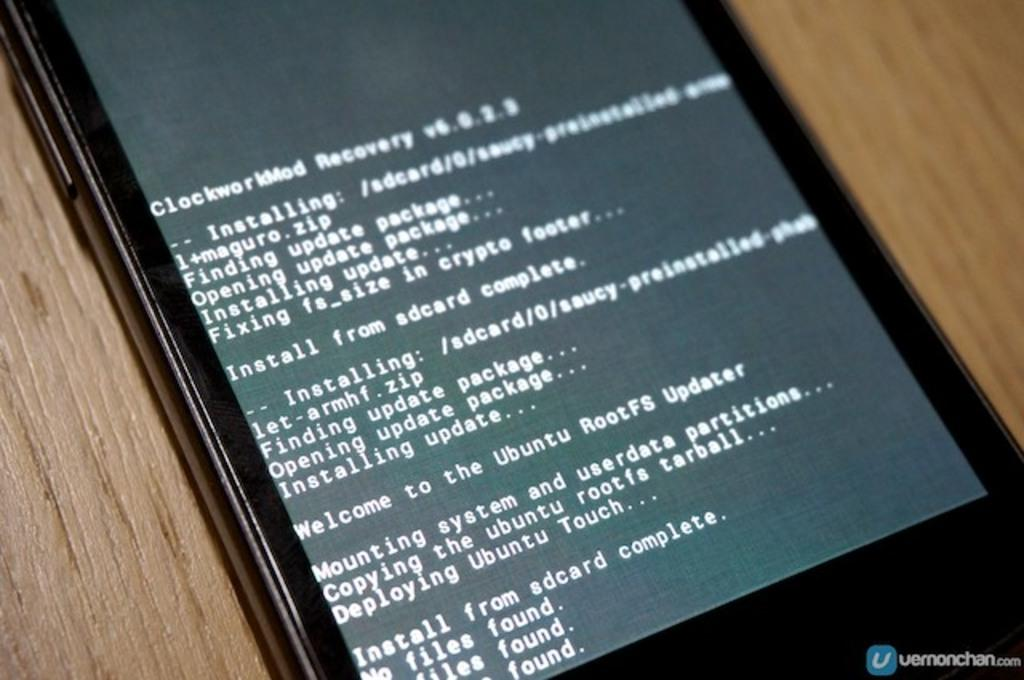<image>
Relay a brief, clear account of the picture shown. a device with text on the screen reading clockworkMod Recovery 